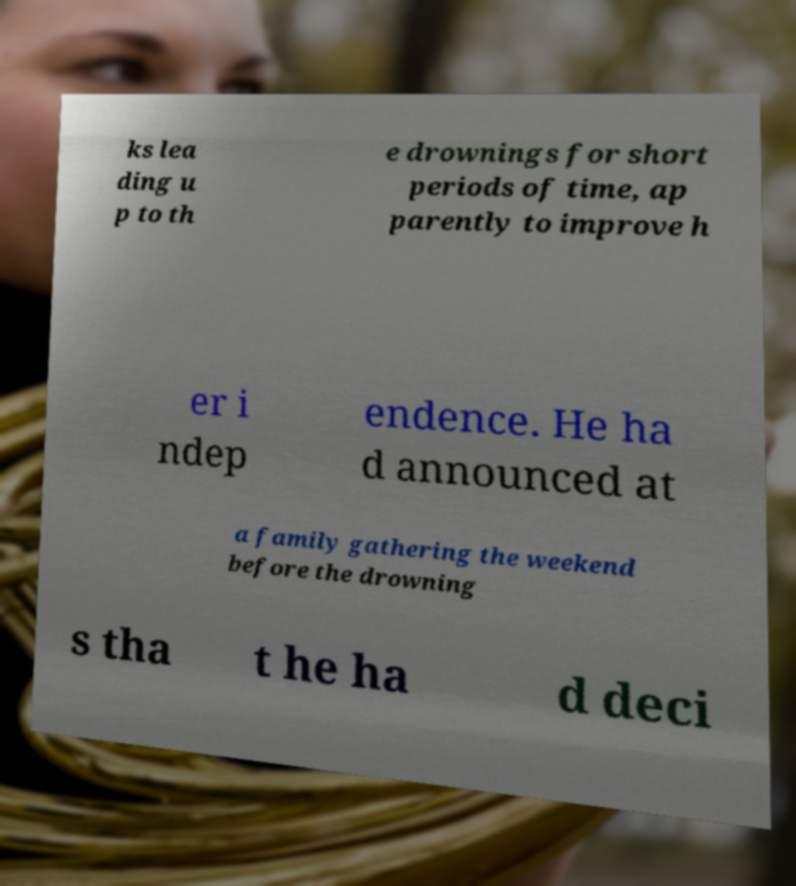Could you extract and type out the text from this image? ks lea ding u p to th e drownings for short periods of time, ap parently to improve h er i ndep endence. He ha d announced at a family gathering the weekend before the drowning s tha t he ha d deci 